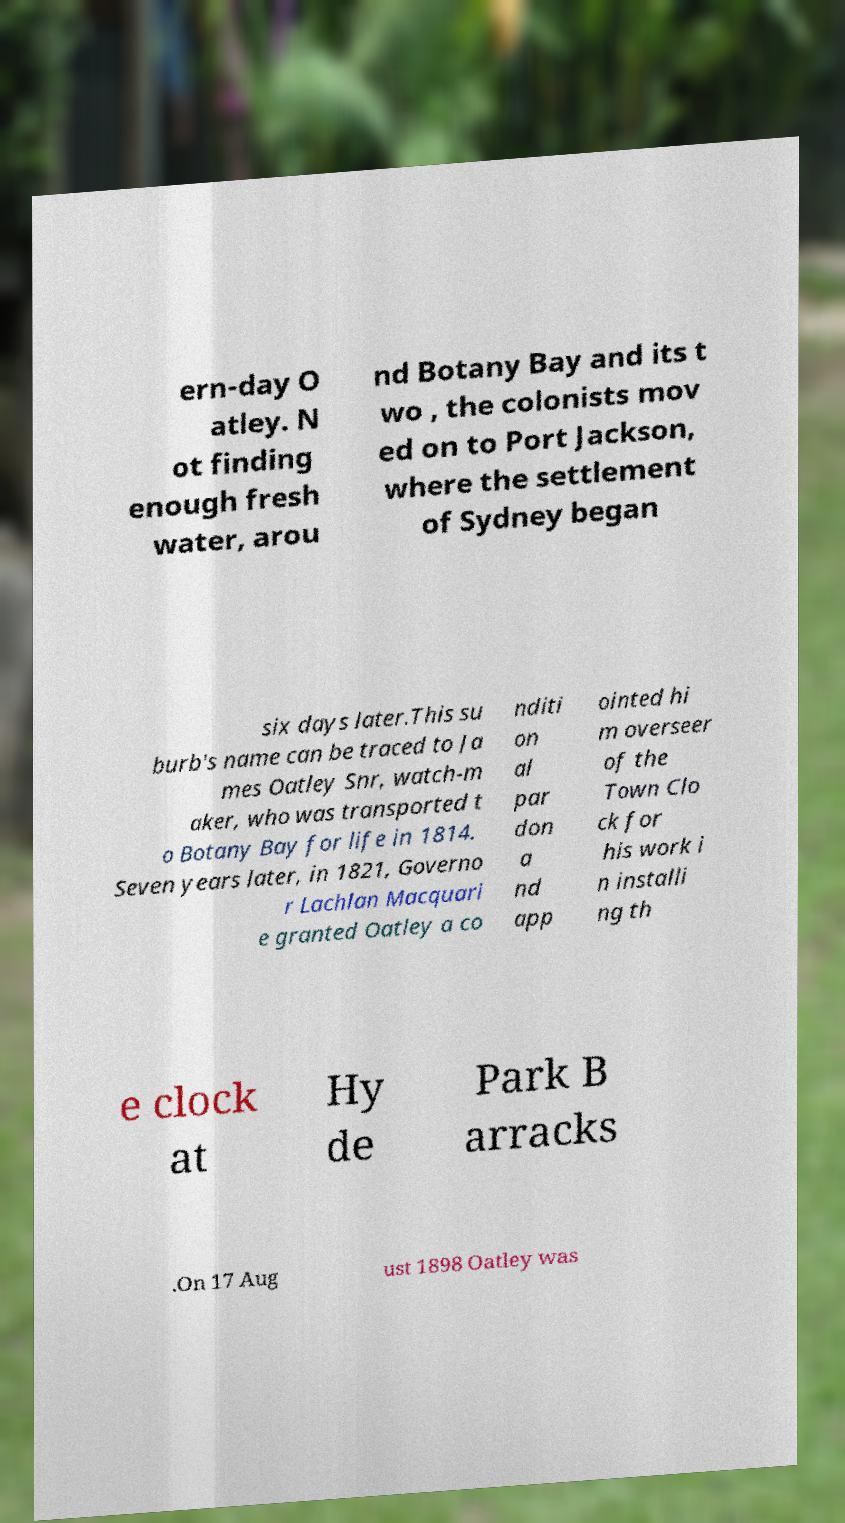There's text embedded in this image that I need extracted. Can you transcribe it verbatim? ern-day O atley. N ot finding enough fresh water, arou nd Botany Bay and its t wo , the colonists mov ed on to Port Jackson, where the settlement of Sydney began six days later.This su burb's name can be traced to Ja mes Oatley Snr, watch-m aker, who was transported t o Botany Bay for life in 1814. Seven years later, in 1821, Governo r Lachlan Macquari e granted Oatley a co nditi on al par don a nd app ointed hi m overseer of the Town Clo ck for his work i n installi ng th e clock at Hy de Park B arracks .On 17 Aug ust 1898 Oatley was 